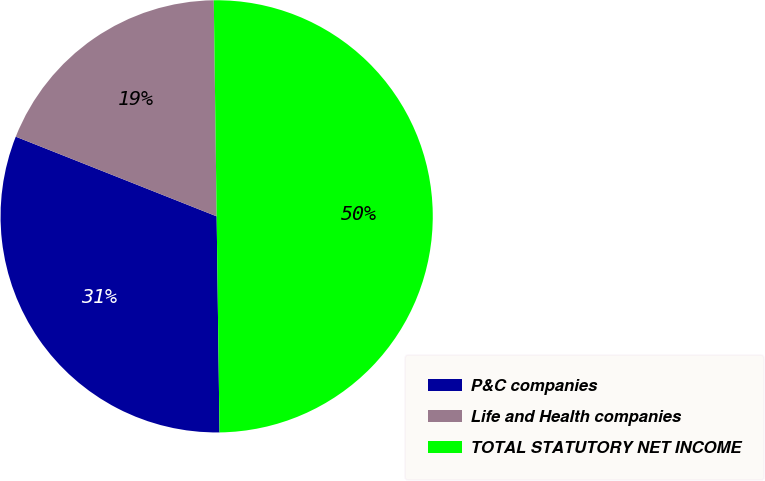Convert chart. <chart><loc_0><loc_0><loc_500><loc_500><pie_chart><fcel>P&C companies<fcel>Life and Health companies<fcel>TOTAL STATUTORY NET INCOME<nl><fcel>31.22%<fcel>18.78%<fcel>50.0%<nl></chart> 